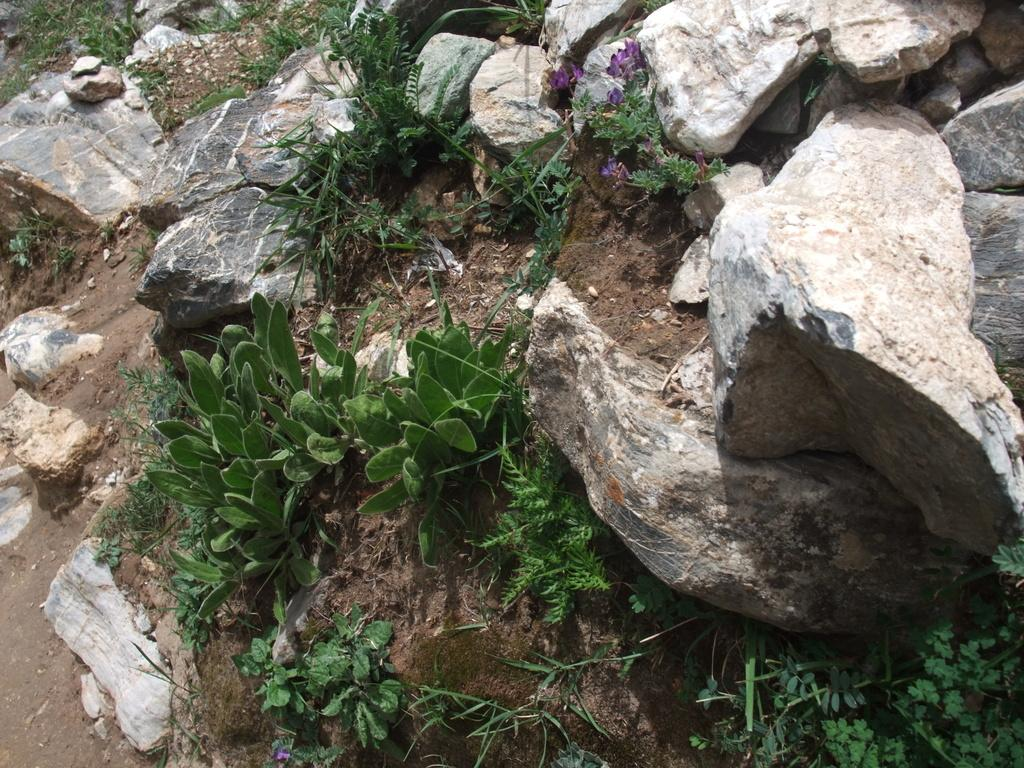What type of natural elements can be seen in the image? There are rocks and plants in the image. Can you describe the rocks in the image? The rocks in the image are likely solid and may have various shapes and sizes. What kind of plants are present in the image? The plants in the image could be any type of vegetation, such as trees, bushes, or flowers. How many cherries are on the rocks in the image? A: There are no cherries present in the image; it only features rocks and plants. What type of ocean can be seen in the background of the image? There is no ocean visible in the image; it only contains rocks and plants. 